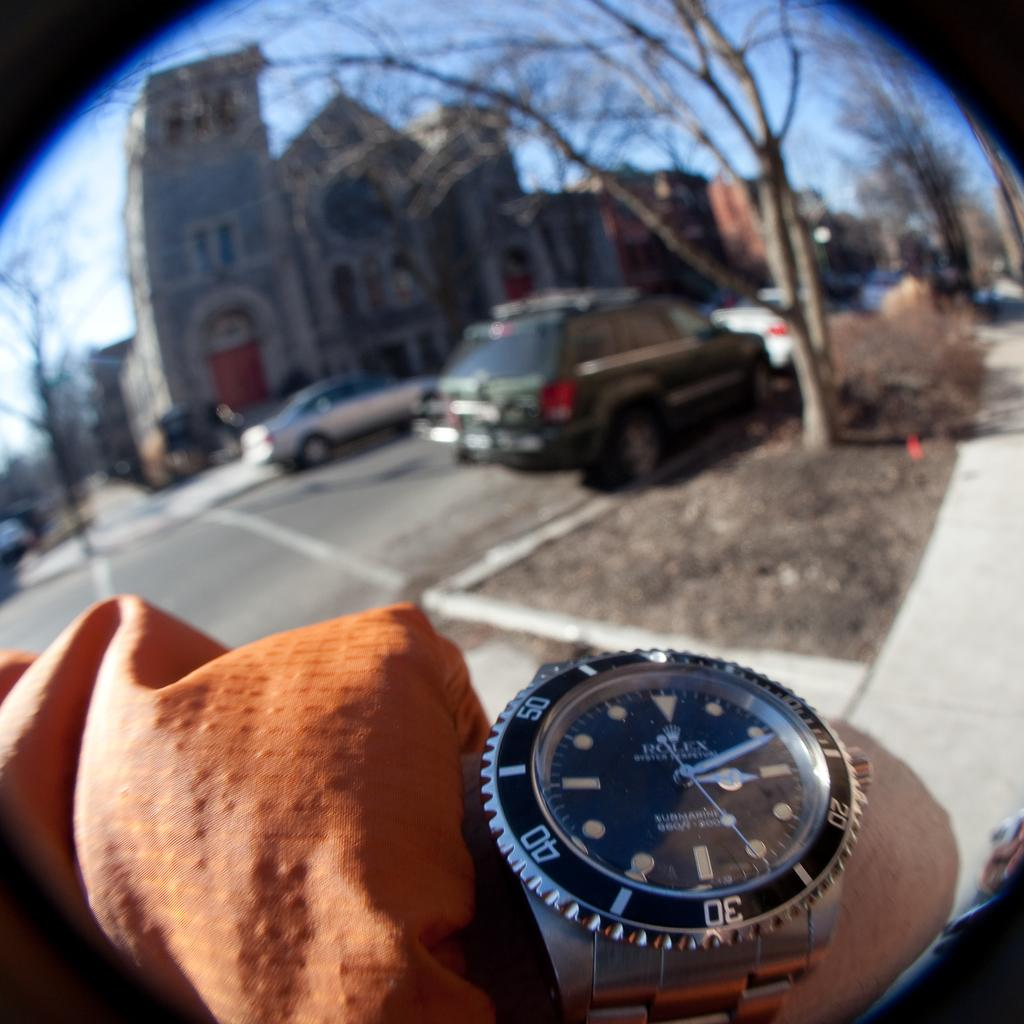<image>
Share a concise interpretation of the image provided. Man wearing a silver and black watch which says ROLEX on the face. 